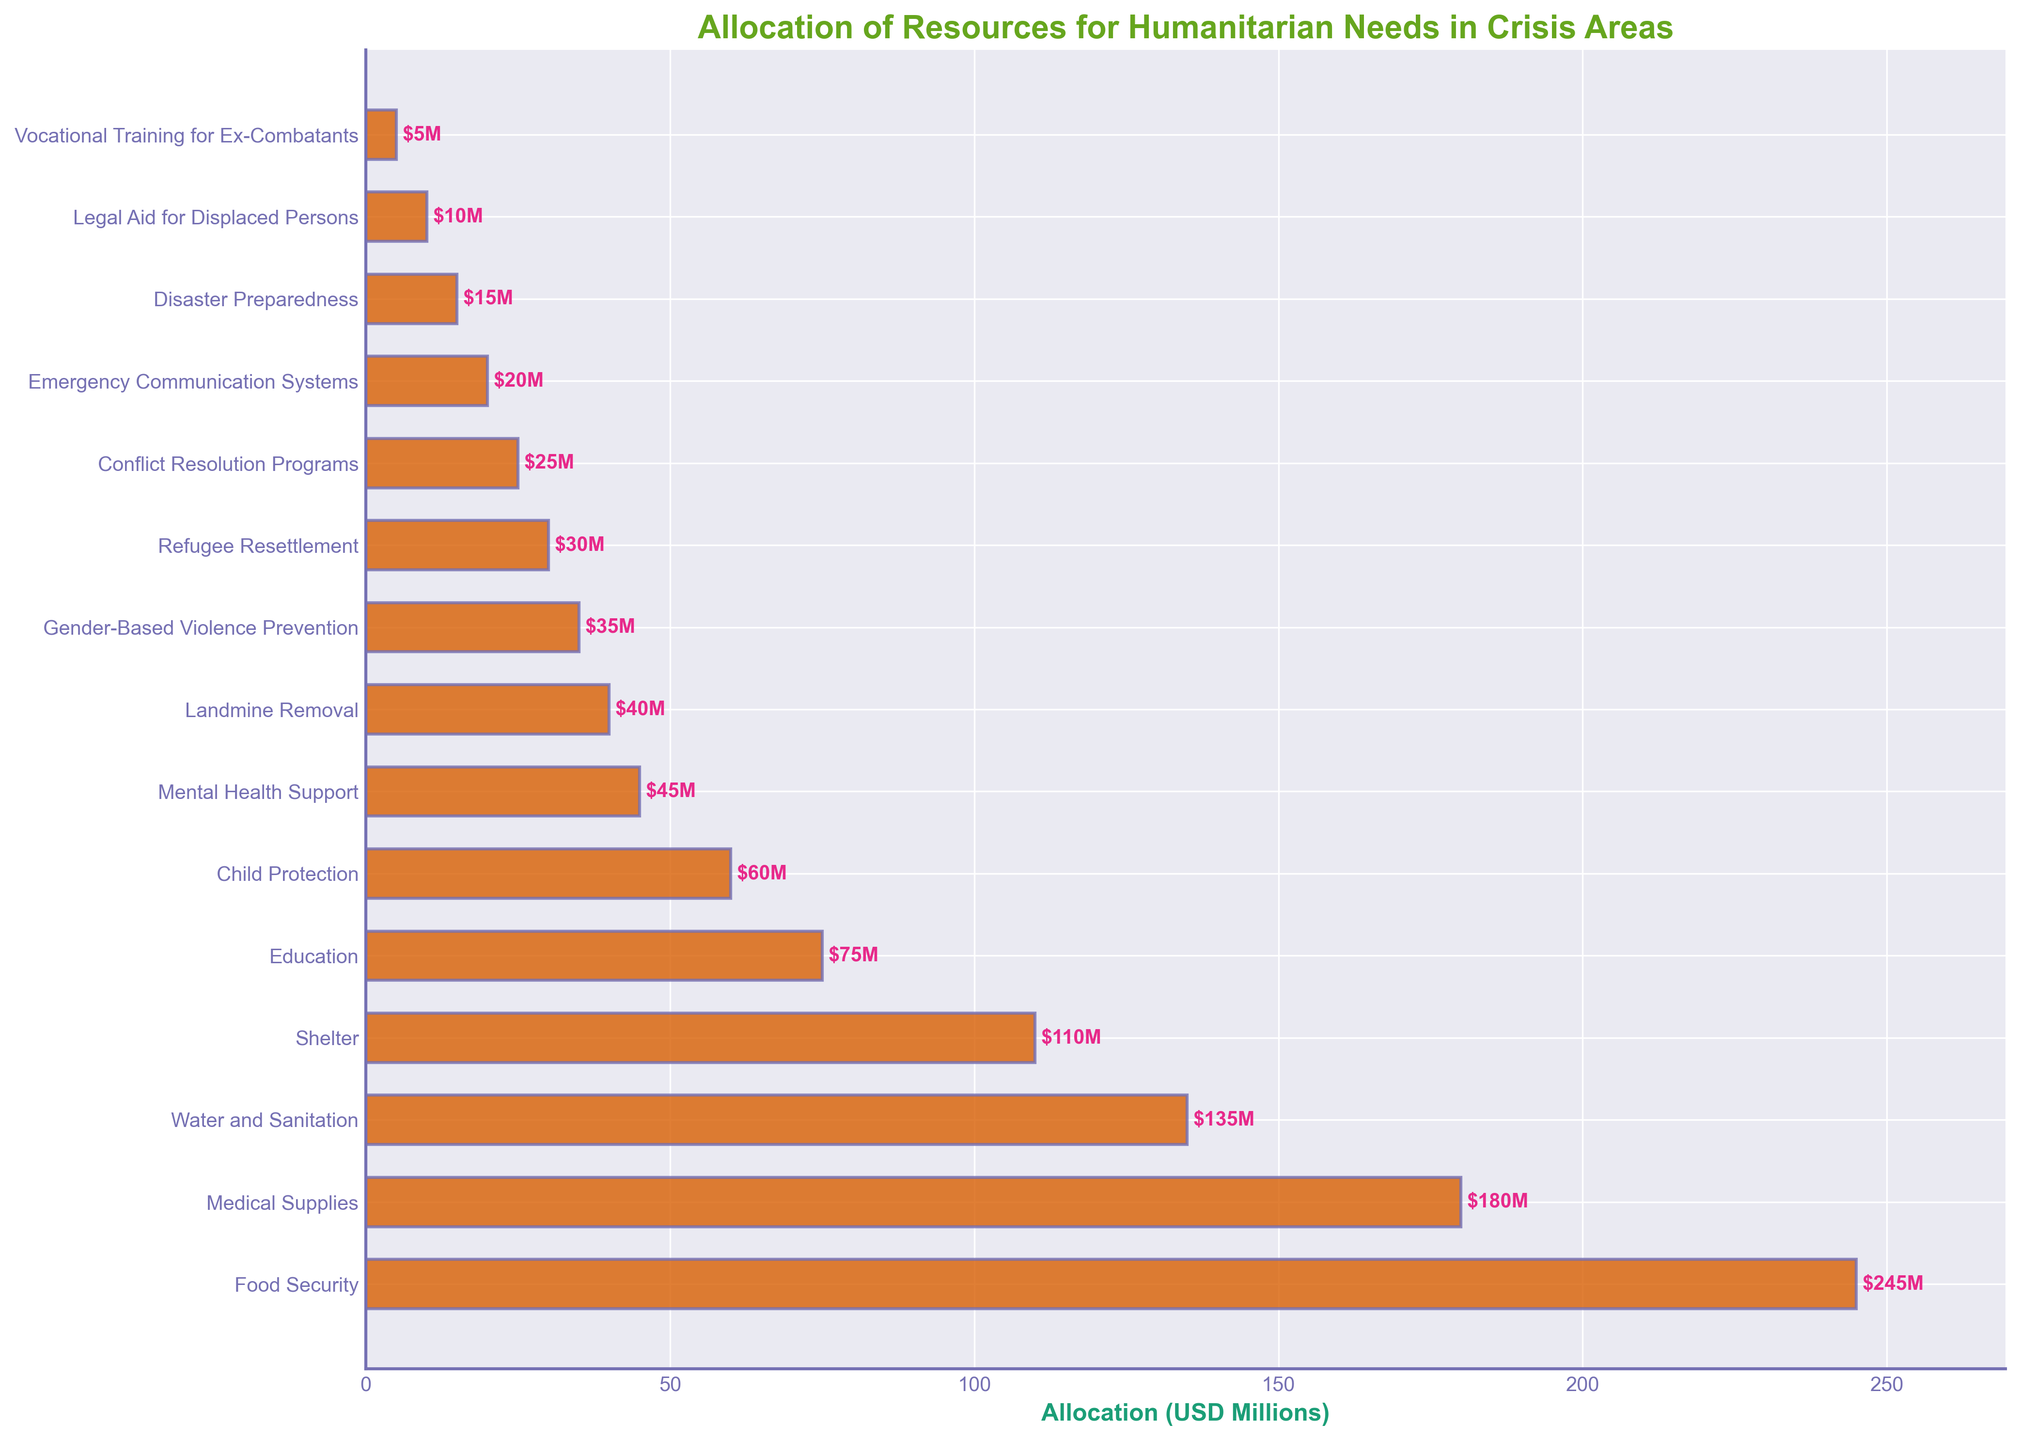What is the total allocation for Food Security and Medical Supplies? Add the allocation for Food Security (245 USD Millions) and Medical Supplies (180 USD Millions): 245 + 180 = 425.
Answer: 425 USD Millions Which humanitarian need has the lowest allocation? Look at the bar chart to identify the shortest bar, which represents Vocational Training for Ex-Combatants with 5 USD Millions.
Answer: Vocational Training for Ex-Combatants How does the allocation for Water and Sanitation compare to that for Shelter? Observe the bar lengths and values: Water and Sanitation has 135 USD Millions, and Shelter has 110 USD Millions. Water and Sanitation has a greater allocation.
Answer: Water and Sanitation has a greater allocation What is the average allocation of resources for Child Protection, Mental Health Support, and Landmine Removal? Sum the allocations for Child Protection (60 USD Millions), Mental Health Support (45 USD Millions), and Landmine Removal (40 USD Millions) and divide by 3: (60 + 45 + 40) / 3 = 145 / 3 ≈ 48.33.
Answer: 48.33 USD Millions If Disaster Preparedness received an additional 15 USD Millions, where would it rank in terms of allocation? Add 15 USD Millions to Disaster Preparedness's current allocation of 15 USD Millions, resulting in 30 USD Millions. Compare this sum to the current allocations: 30 USD Millions would be equal to the allocation for Refugee Resettlement, joint tenth place.
Answer: 10th place (tied with Refugee Resettlement) What is the difference in allocation between Conflict Resolution Programs and Emergency Communication Systems? Subtract the allocation for Emergency Communication Systems (20 USD Millions) from the allocation for Conflict Resolution Programs (25 USD Millions): 25 - 20 = 5.
Answer: 5 USD Millions Which need has an allocation closest to the median of all the allocations? List allocations in ascending order and find the middle value: 5, 10, 15, 20, 25, 30, 35, 40, 45, 60, 75, 110, 135, 180, 245. The median is 40 USD Millions, which is the allocation for Landmine Removal.
Answer: Landmine Removal Is the allocation for Gender-Based Violence Prevention higher than the combined allocation for Legal Aid for Displaced Persons and Vocational Training for Ex-Combatants? The allocation for Gender-Based Violence Prevention is 35 USD Millions. The combined allocation for Legal Aid for Displaced Persons (10 USD Millions) and Vocational Training for Ex-Combatants (5 USD Millions) is 15 USD Millions. 35 > 15.
Answer: Yes What percentage of the total allocation is dedicated to Shelter? Calculate the total allocation (sum of all values) and the allocation for Shelter: Total = 245 + 180 + 135 + 110 + 75 + 60 + 45 + 40 + 35 + 30 + 25 + 20 + 15 + 10 + 5 = 1030 USD Millions. Percentage for Shelter = (110 / 1030) * 100 ≈ 10.68%.
Answer: 10.68% How many needs have an allocation of less than 50 USD Millions? Count the bars with values less than 50: Mental Health Support (45), Landmine Removal (40), Gender-Based Violence Prevention (35), Refugee Resettlement (30), Conflict Resolution Programs (25), Emergency Communication Systems (20), Disaster Preparedness (15), Legal Aid for Displaced Persons (10), Vocational Training for Ex-Combatants (5) — 9 needs.
Answer: 9 needs 